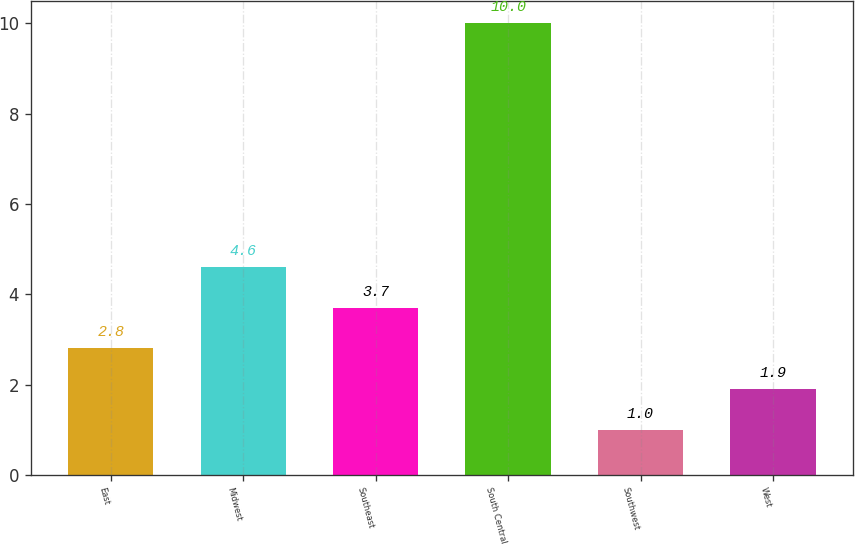Convert chart to OTSL. <chart><loc_0><loc_0><loc_500><loc_500><bar_chart><fcel>East<fcel>Midwest<fcel>Southeast<fcel>South Central<fcel>Southwest<fcel>West<nl><fcel>2.8<fcel>4.6<fcel>3.7<fcel>10<fcel>1<fcel>1.9<nl></chart> 